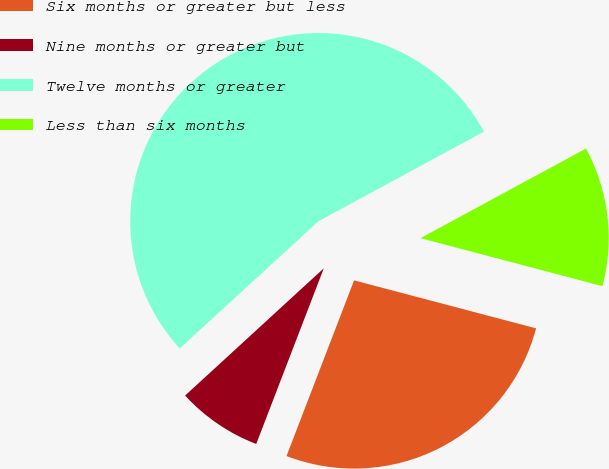Convert chart to OTSL. <chart><loc_0><loc_0><loc_500><loc_500><pie_chart><fcel>Six months or greater but less<fcel>Nine months or greater but<fcel>Twelve months or greater<fcel>Less than six months<nl><fcel>26.74%<fcel>7.34%<fcel>53.92%<fcel>12.0%<nl></chart> 